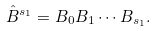<formula> <loc_0><loc_0><loc_500><loc_500>\hat { B } ^ { s _ { 1 } } = B _ { 0 } B _ { 1 } \cdots B _ { s _ { 1 } } .</formula> 